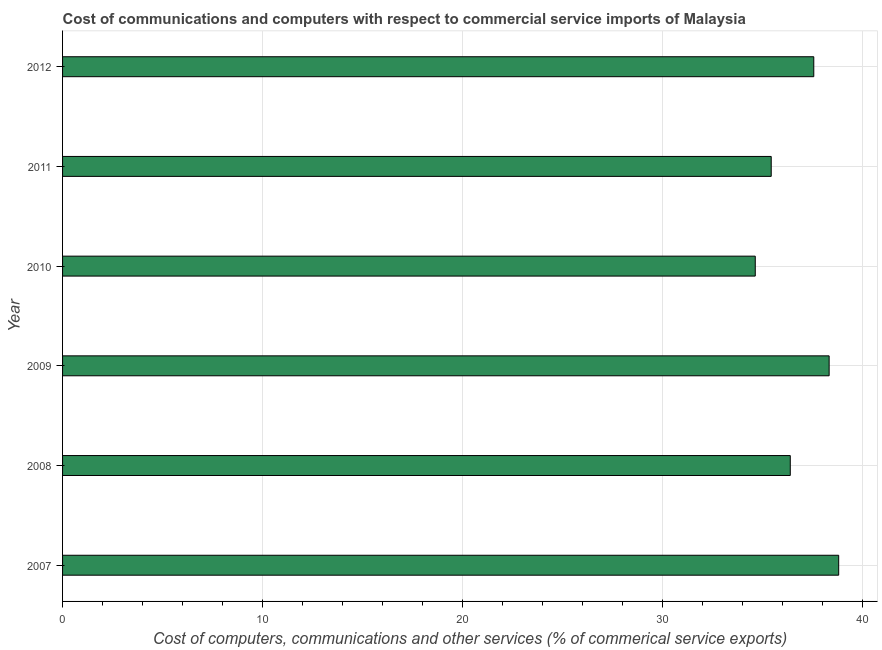Does the graph contain any zero values?
Provide a succinct answer. No. Does the graph contain grids?
Keep it short and to the point. Yes. What is the title of the graph?
Offer a terse response. Cost of communications and computers with respect to commercial service imports of Malaysia. What is the label or title of the X-axis?
Offer a terse response. Cost of computers, communications and other services (% of commerical service exports). What is the label or title of the Y-axis?
Give a very brief answer. Year. What is the cost of communications in 2012?
Offer a very short reply. 37.54. Across all years, what is the maximum  computer and other services?
Your answer should be very brief. 38.79. Across all years, what is the minimum  computer and other services?
Give a very brief answer. 34.62. What is the sum of the  computer and other services?
Make the answer very short. 221.03. What is the difference between the cost of communications in 2009 and 2012?
Keep it short and to the point. 0.77. What is the average  computer and other services per year?
Your answer should be compact. 36.84. What is the median  computer and other services?
Give a very brief answer. 36.95. In how many years, is the  computer and other services greater than 22 %?
Your answer should be compact. 6. Do a majority of the years between 2009 and 2012 (inclusive) have  computer and other services greater than 26 %?
Your response must be concise. Yes. What is the ratio of the  computer and other services in 2011 to that in 2012?
Keep it short and to the point. 0.94. Is the  computer and other services in 2007 less than that in 2008?
Your answer should be very brief. No. What is the difference between the highest and the second highest  computer and other services?
Your answer should be very brief. 0.48. What is the difference between the highest and the lowest cost of communications?
Your answer should be very brief. 4.17. How many bars are there?
Provide a short and direct response. 6. Are all the bars in the graph horizontal?
Offer a terse response. Yes. What is the difference between two consecutive major ticks on the X-axis?
Provide a succinct answer. 10. What is the Cost of computers, communications and other services (% of commerical service exports) of 2007?
Keep it short and to the point. 38.79. What is the Cost of computers, communications and other services (% of commerical service exports) in 2008?
Keep it short and to the point. 36.37. What is the Cost of computers, communications and other services (% of commerical service exports) of 2009?
Provide a short and direct response. 38.31. What is the Cost of computers, communications and other services (% of commerical service exports) in 2010?
Offer a very short reply. 34.62. What is the Cost of computers, communications and other services (% of commerical service exports) of 2011?
Provide a succinct answer. 35.41. What is the Cost of computers, communications and other services (% of commerical service exports) of 2012?
Ensure brevity in your answer.  37.54. What is the difference between the Cost of computers, communications and other services (% of commerical service exports) in 2007 and 2008?
Give a very brief answer. 2.42. What is the difference between the Cost of computers, communications and other services (% of commerical service exports) in 2007 and 2009?
Your response must be concise. 0.48. What is the difference between the Cost of computers, communications and other services (% of commerical service exports) in 2007 and 2010?
Provide a succinct answer. 4.17. What is the difference between the Cost of computers, communications and other services (% of commerical service exports) in 2007 and 2011?
Offer a terse response. 3.37. What is the difference between the Cost of computers, communications and other services (% of commerical service exports) in 2007 and 2012?
Your response must be concise. 1.24. What is the difference between the Cost of computers, communications and other services (% of commerical service exports) in 2008 and 2009?
Ensure brevity in your answer.  -1.94. What is the difference between the Cost of computers, communications and other services (% of commerical service exports) in 2008 and 2010?
Offer a very short reply. 1.75. What is the difference between the Cost of computers, communications and other services (% of commerical service exports) in 2008 and 2011?
Your answer should be very brief. 0.95. What is the difference between the Cost of computers, communications and other services (% of commerical service exports) in 2008 and 2012?
Your response must be concise. -1.17. What is the difference between the Cost of computers, communications and other services (% of commerical service exports) in 2009 and 2010?
Offer a terse response. 3.69. What is the difference between the Cost of computers, communications and other services (% of commerical service exports) in 2009 and 2011?
Provide a succinct answer. 2.89. What is the difference between the Cost of computers, communications and other services (% of commerical service exports) in 2009 and 2012?
Your answer should be very brief. 0.77. What is the difference between the Cost of computers, communications and other services (% of commerical service exports) in 2010 and 2011?
Provide a succinct answer. -0.8. What is the difference between the Cost of computers, communications and other services (% of commerical service exports) in 2010 and 2012?
Offer a terse response. -2.92. What is the difference between the Cost of computers, communications and other services (% of commerical service exports) in 2011 and 2012?
Provide a short and direct response. -2.13. What is the ratio of the Cost of computers, communications and other services (% of commerical service exports) in 2007 to that in 2008?
Your answer should be compact. 1.07. What is the ratio of the Cost of computers, communications and other services (% of commerical service exports) in 2007 to that in 2009?
Ensure brevity in your answer.  1.01. What is the ratio of the Cost of computers, communications and other services (% of commerical service exports) in 2007 to that in 2010?
Keep it short and to the point. 1.12. What is the ratio of the Cost of computers, communications and other services (% of commerical service exports) in 2007 to that in 2011?
Ensure brevity in your answer.  1.09. What is the ratio of the Cost of computers, communications and other services (% of commerical service exports) in 2007 to that in 2012?
Your response must be concise. 1.03. What is the ratio of the Cost of computers, communications and other services (% of commerical service exports) in 2008 to that in 2009?
Offer a terse response. 0.95. What is the ratio of the Cost of computers, communications and other services (% of commerical service exports) in 2008 to that in 2010?
Offer a terse response. 1.05. What is the ratio of the Cost of computers, communications and other services (% of commerical service exports) in 2009 to that in 2010?
Provide a succinct answer. 1.11. What is the ratio of the Cost of computers, communications and other services (% of commerical service exports) in 2009 to that in 2011?
Your response must be concise. 1.08. What is the ratio of the Cost of computers, communications and other services (% of commerical service exports) in 2010 to that in 2012?
Your response must be concise. 0.92. What is the ratio of the Cost of computers, communications and other services (% of commerical service exports) in 2011 to that in 2012?
Offer a very short reply. 0.94. 